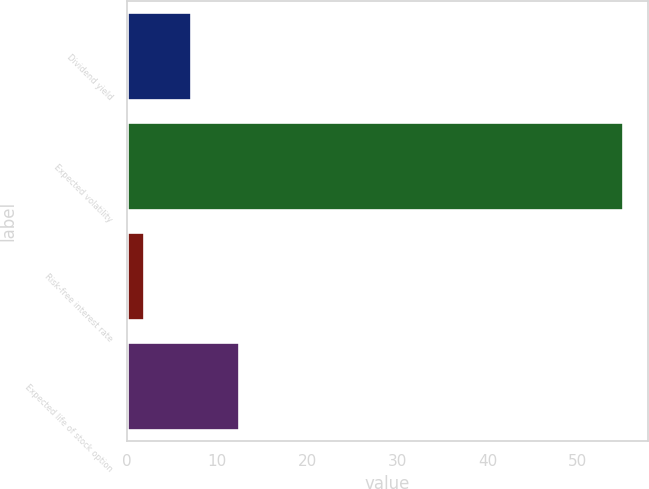Convert chart to OTSL. <chart><loc_0><loc_0><loc_500><loc_500><bar_chart><fcel>Dividend yield<fcel>Expected volatility<fcel>Risk-free interest rate<fcel>Expected life of stock option<nl><fcel>7.12<fcel>55<fcel>1.8<fcel>12.44<nl></chart> 